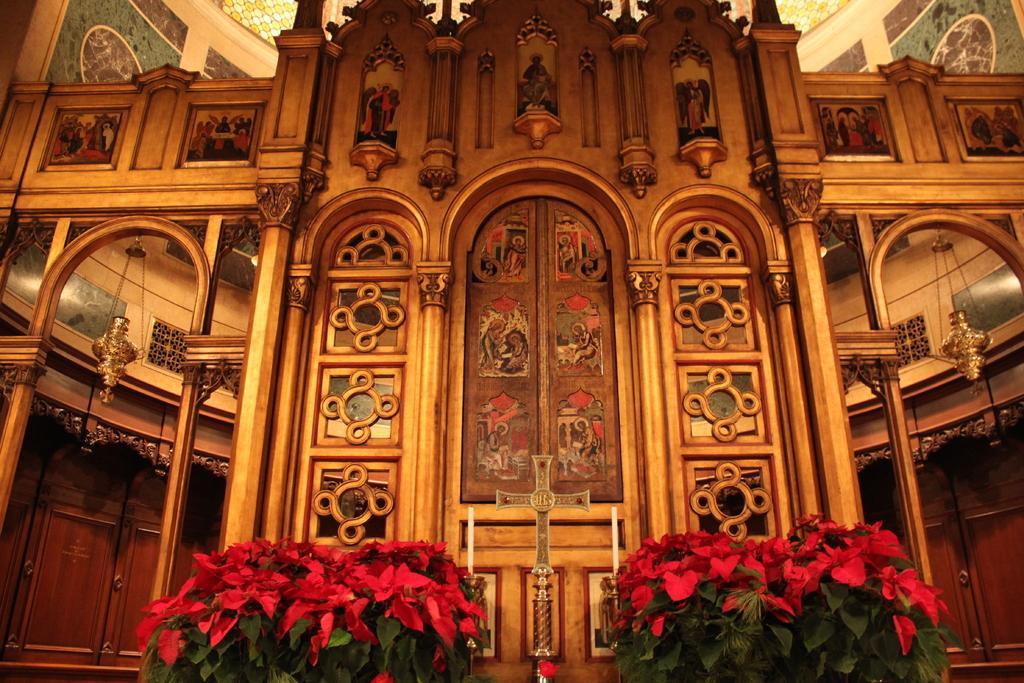Could you give a brief overview of what you see in this image? In this image it seems like it is a church. In the middle there is a cross symbol and there are two flower plants on either side of the symbol. There are hangings on either side of the church. On the wall there is some design. 